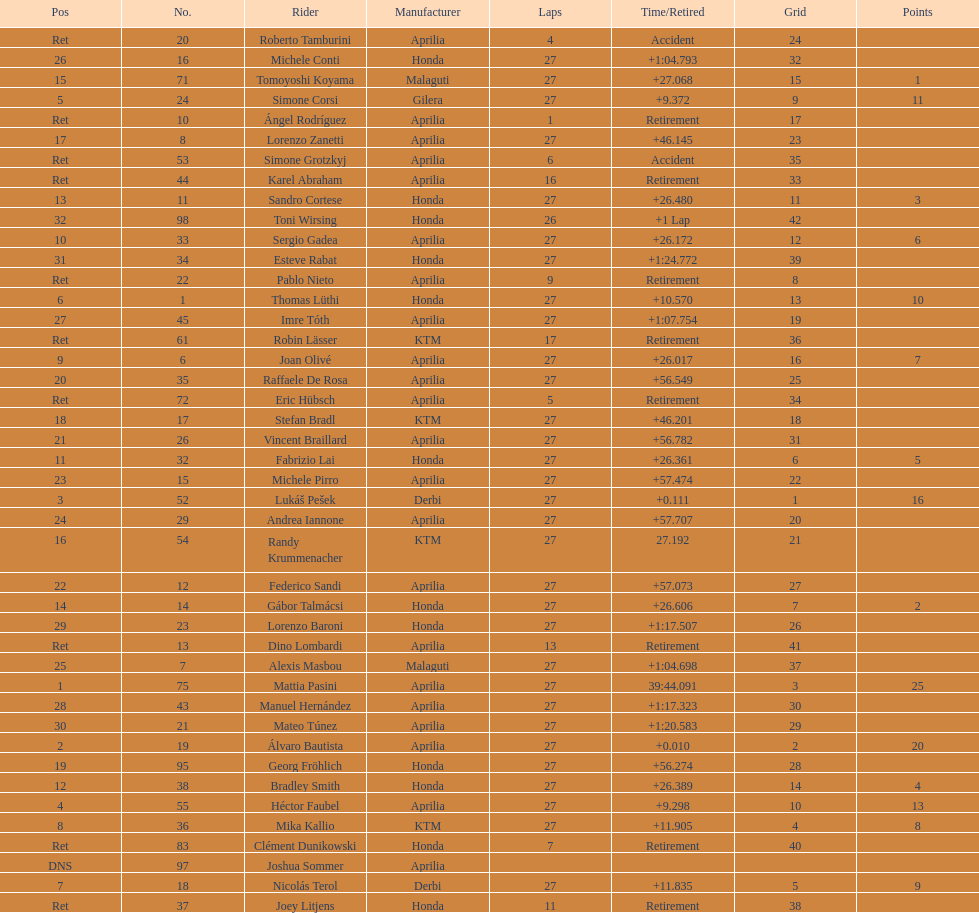Out of all the people who have points, who has the least? Tomoyoshi Koyama. 